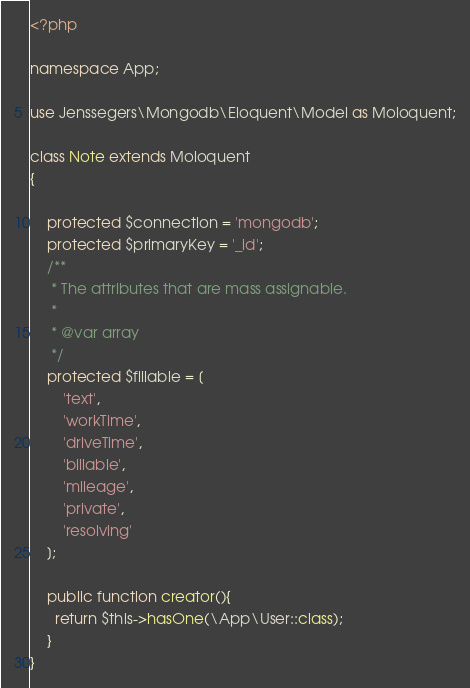<code> <loc_0><loc_0><loc_500><loc_500><_PHP_><?php

namespace App;

use Jenssegers\Mongodb\Eloquent\Model as Moloquent;

class Note extends Moloquent
{

    protected $connection = 'mongodb';
    protected $primaryKey = '_id';
    /**
     * The attributes that are mass assignable.
     *
     * @var array
     */
    protected $fillable = [
        'text',
        'workTime',
        'driveTime',
        'billable',
        'mileage',
        'private',
        'resolving'
    ];

    public function creator(){
      return $this->hasOne(\App\User::class);
    }
}
</code> 